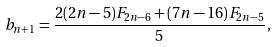Convert formula to latex. <formula><loc_0><loc_0><loc_500><loc_500>b _ { n + 1 } = \frac { 2 ( 2 n - 5 ) F _ { 2 n - 6 } + ( 7 n - 1 6 ) F _ { 2 n - 5 } } { 5 } ,</formula> 